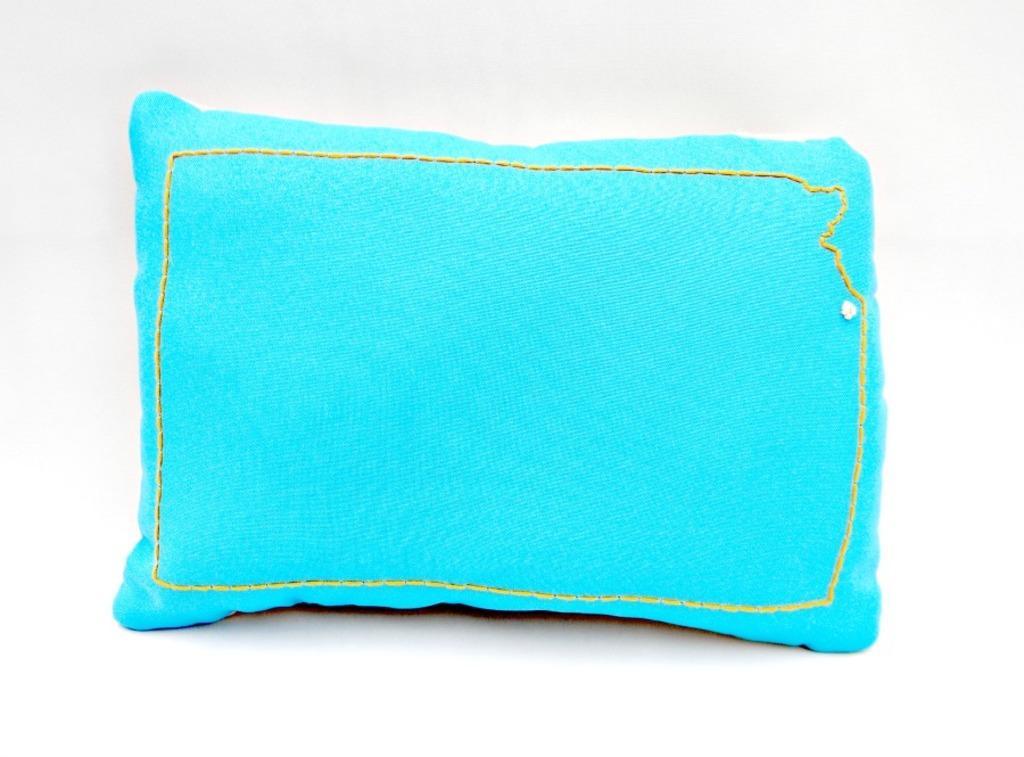Describe this image in one or two sentences. In the center of the image there is a pillow. 